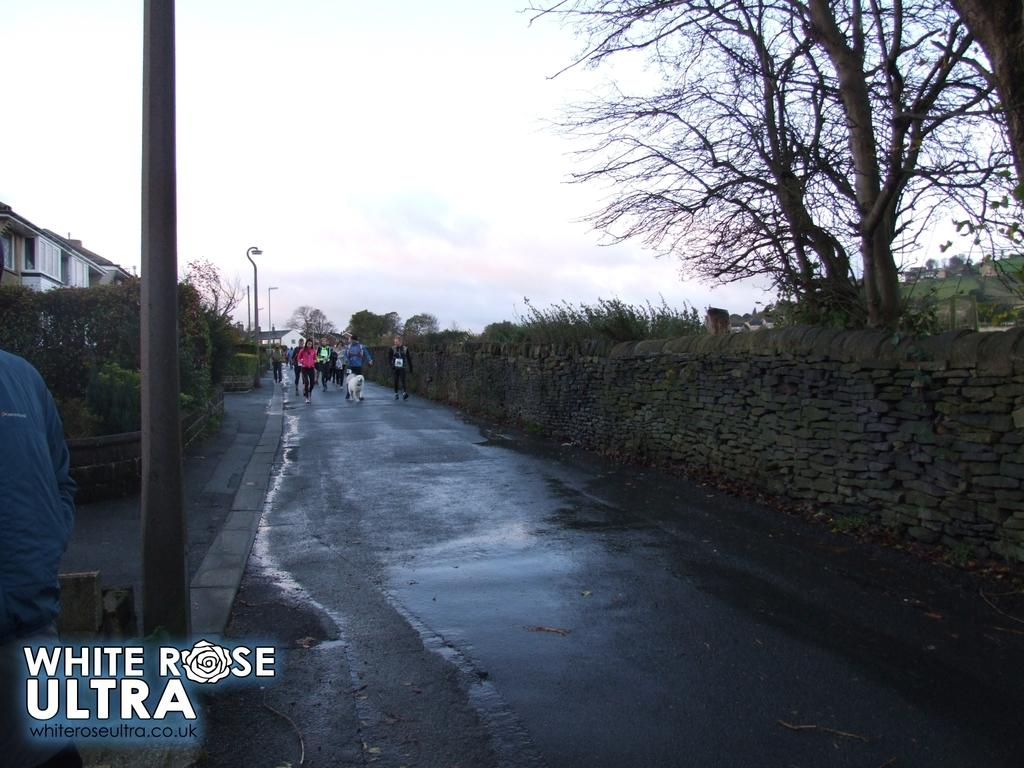<image>
Create a compact narrative representing the image presented. A group of people being led by a large white fluffy dog at teh White Rose Ultra marathon. 